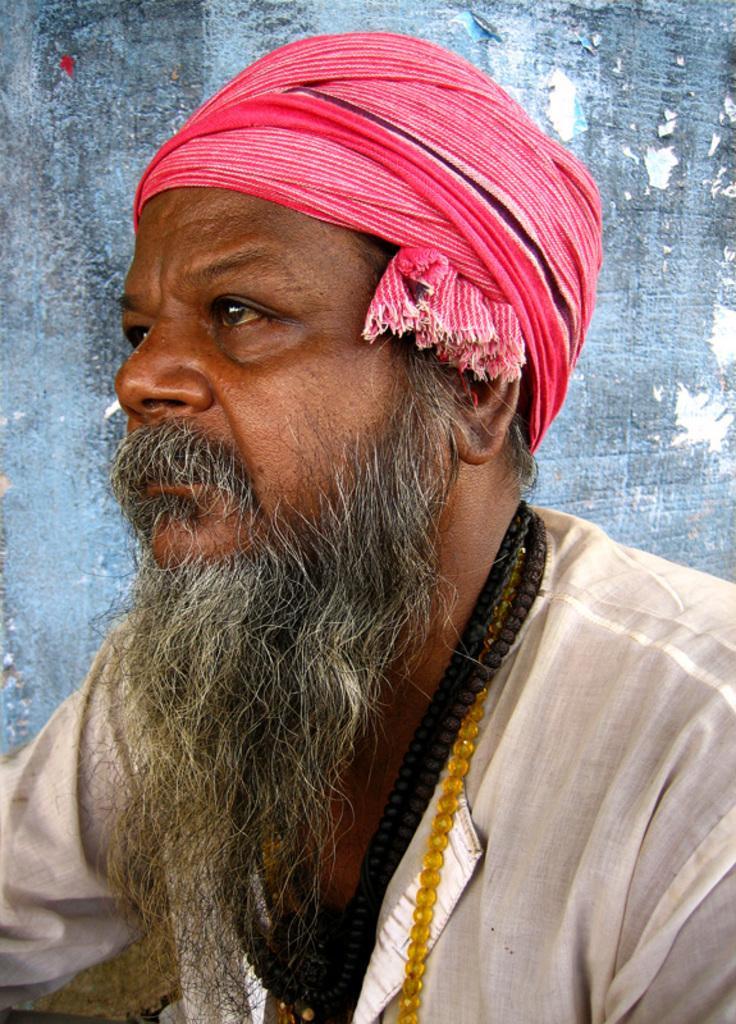Could you give a brief overview of what you see in this image? In this image in front there is a person. Behind him there is a wall. 